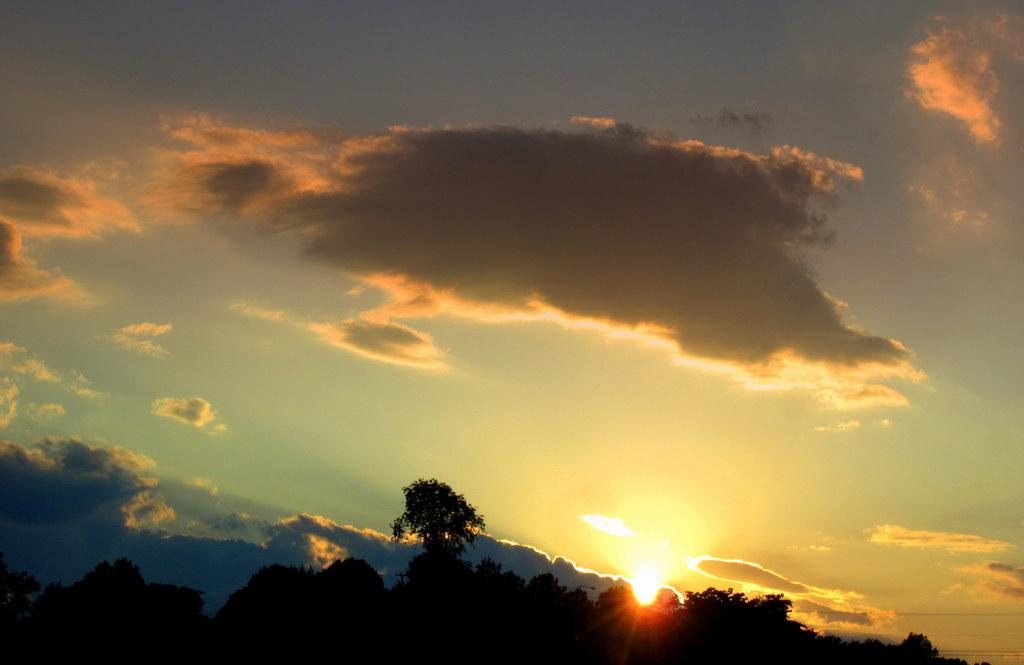What type of vegetation is at the bottom of the image? There are trees at the bottom of the image. What is visible at the top of the image? The sky is visible at the top of the image. What can be seen in the sky? There are clouds in the sky. Can you tell me how many rats are sitting on the clouds in the image? There are no rats present in the image; it only features trees and clouds in the sky. Is the person's brother visible in the image? There is no person or brother mentioned in the image; it only includes trees, clouds, and the sky. 